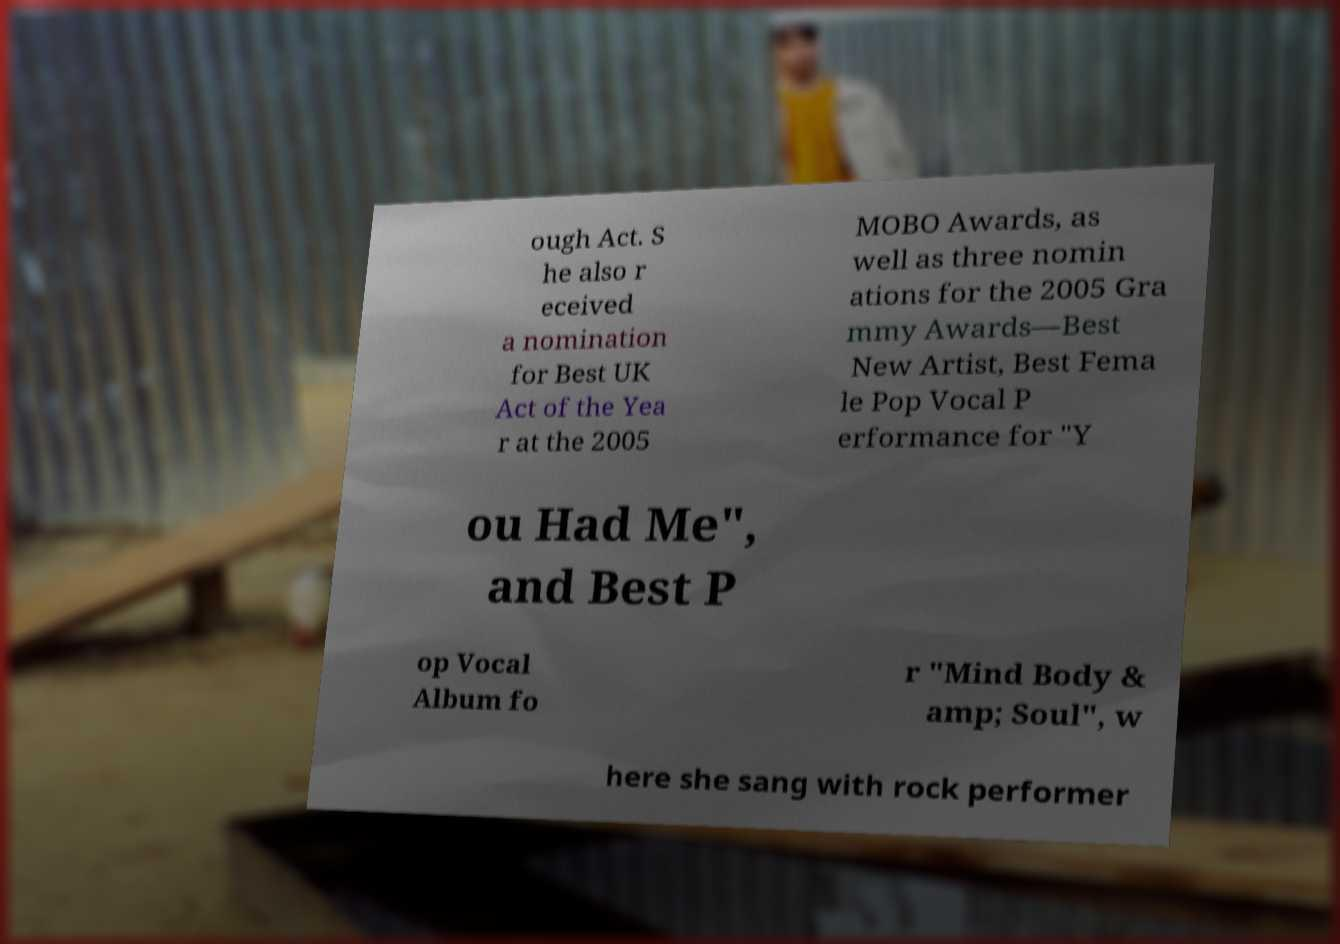There's text embedded in this image that I need extracted. Can you transcribe it verbatim? ough Act. S he also r eceived a nomination for Best UK Act of the Yea r at the 2005 MOBO Awards, as well as three nomin ations for the 2005 Gra mmy Awards—Best New Artist, Best Fema le Pop Vocal P erformance for "Y ou Had Me", and Best P op Vocal Album fo r "Mind Body & amp; Soul", w here she sang with rock performer 